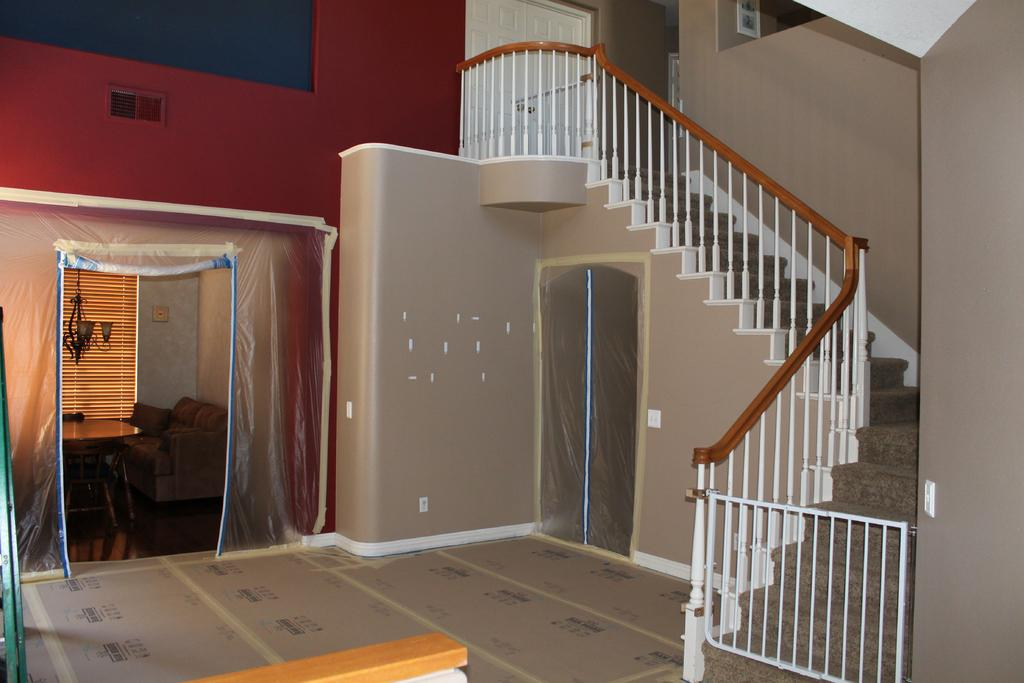What type of space is depicted in the image? The image shows the inside view of a house. What architectural feature can be seen in the image? There are stairs in the image. What safety feature is present near the stairs? There is a railing in the image. What type of furniture is visible in the image? There is a sofa and a table in the image. What is a source of natural light in the image? There is a window in the image. What structural elements can be seen in the image? There are walls in the image. What part of the house is visible in the image? The floor is visible in the image. What type of curve can be seen in the earth's surface in the image? There is no reference to the earth or any curves in the image; it shows the inside of a house. 